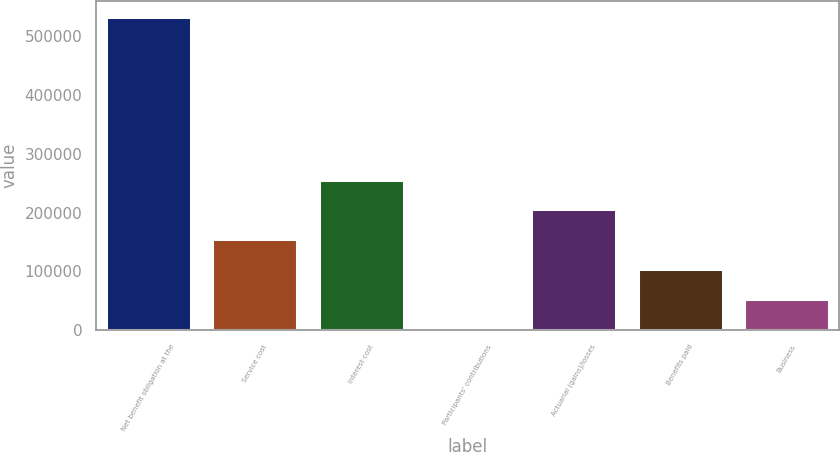Convert chart to OTSL. <chart><loc_0><loc_0><loc_500><loc_500><bar_chart><fcel>Net benefit obligation at the<fcel>Service cost<fcel>Interest cost<fcel>Participants' contributions<fcel>Actuarial (gains)/losses<fcel>Benefits paid<fcel>Business<nl><fcel>533182<fcel>155122<fcel>256402<fcel>3200<fcel>205762<fcel>104481<fcel>53840.5<nl></chart> 